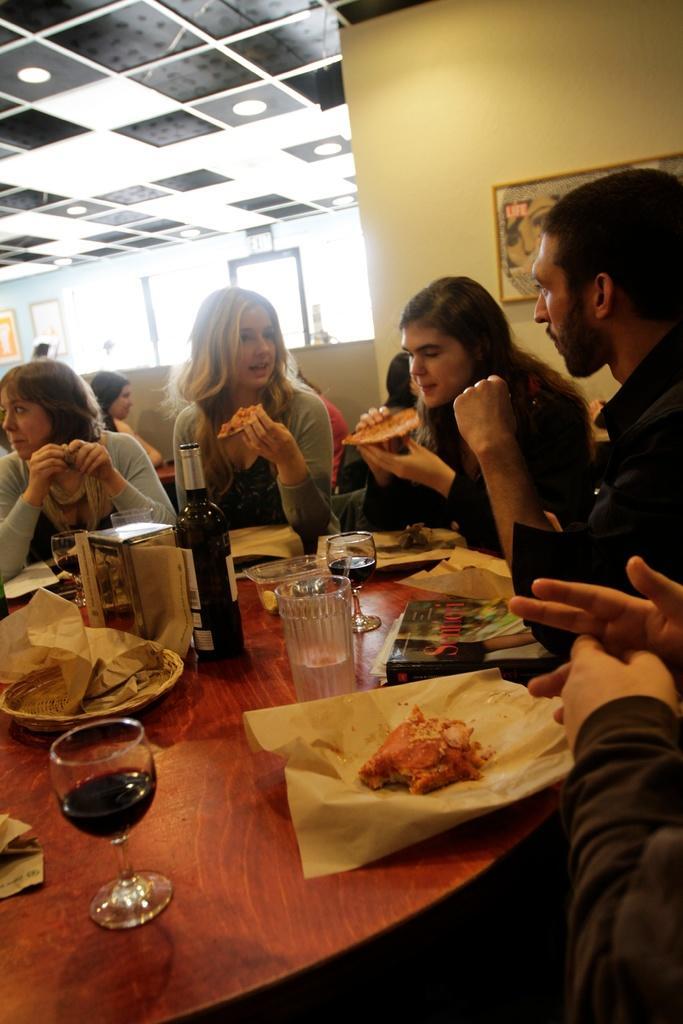How would you summarize this image in a sentence or two? This picture describes about group of people they are all in the restaurant, in front of them we can find a bottle, glasses, plates, books on the table, in the background we can see a wall painting on the wall. 